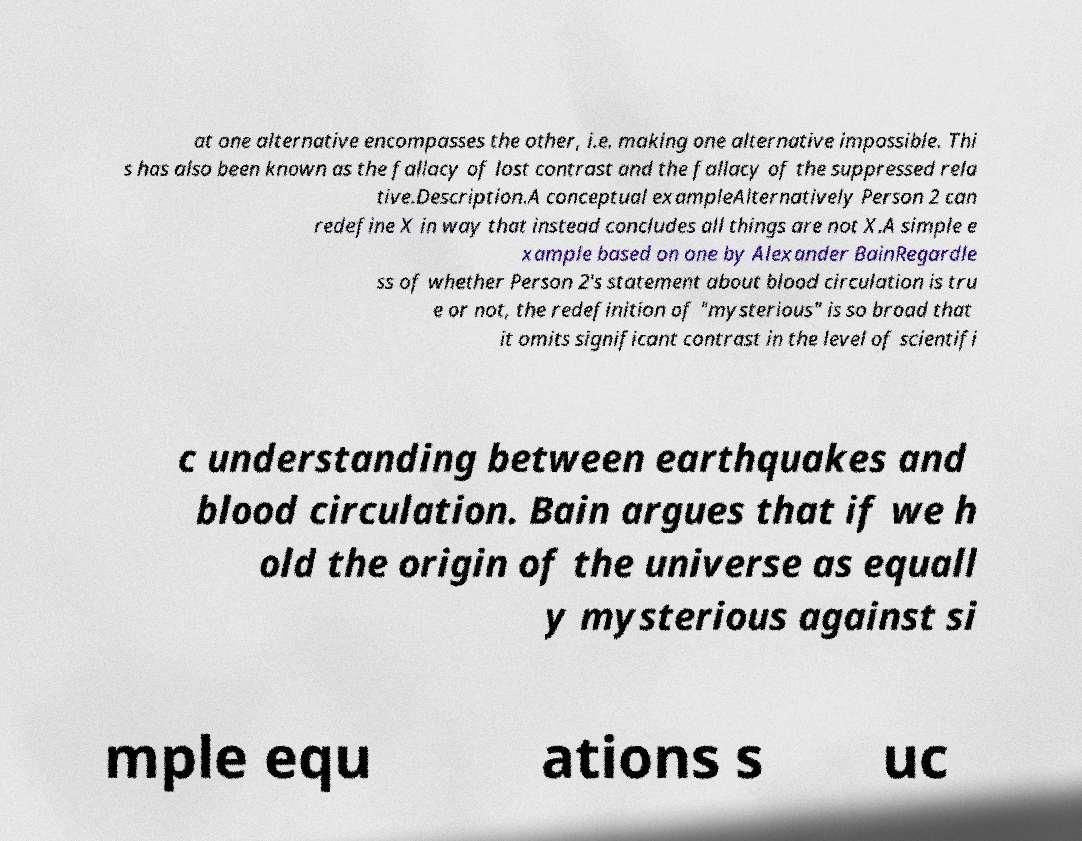For documentation purposes, I need the text within this image transcribed. Could you provide that? at one alternative encompasses the other, i.e. making one alternative impossible. Thi s has also been known as the fallacy of lost contrast and the fallacy of the suppressed rela tive.Description.A conceptual exampleAlternatively Person 2 can redefine X in way that instead concludes all things are not X.A simple e xample based on one by Alexander BainRegardle ss of whether Person 2's statement about blood circulation is tru e or not, the redefinition of "mysterious" is so broad that it omits significant contrast in the level of scientifi c understanding between earthquakes and blood circulation. Bain argues that if we h old the origin of the universe as equall y mysterious against si mple equ ations s uc 